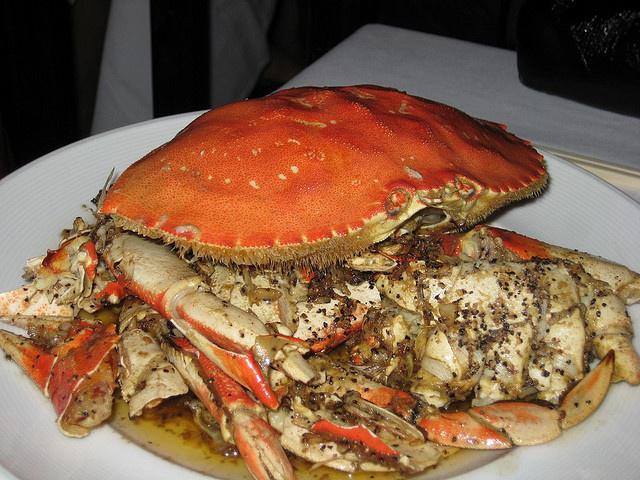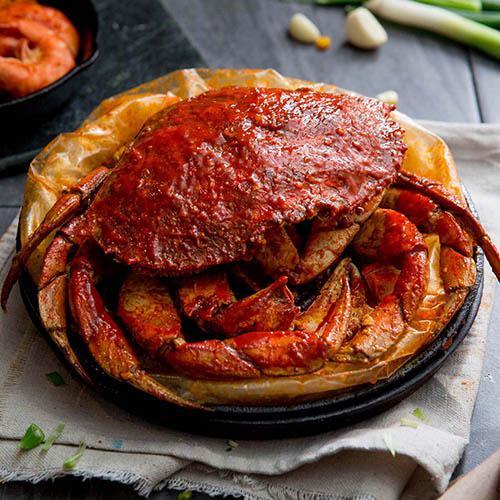The first image is the image on the left, the second image is the image on the right. Considering the images on both sides, is "One image shows one crab on a plate next to green beans, and the other image shows at least one crab that is facing forward and not on a plate with other food items." valid? Answer yes or no. No. The first image is the image on the left, the second image is the image on the right. Analyze the images presented: Is the assertion "Green vegetables are served in the plate with the crab in one of the dishes." valid? Answer yes or no. No. 